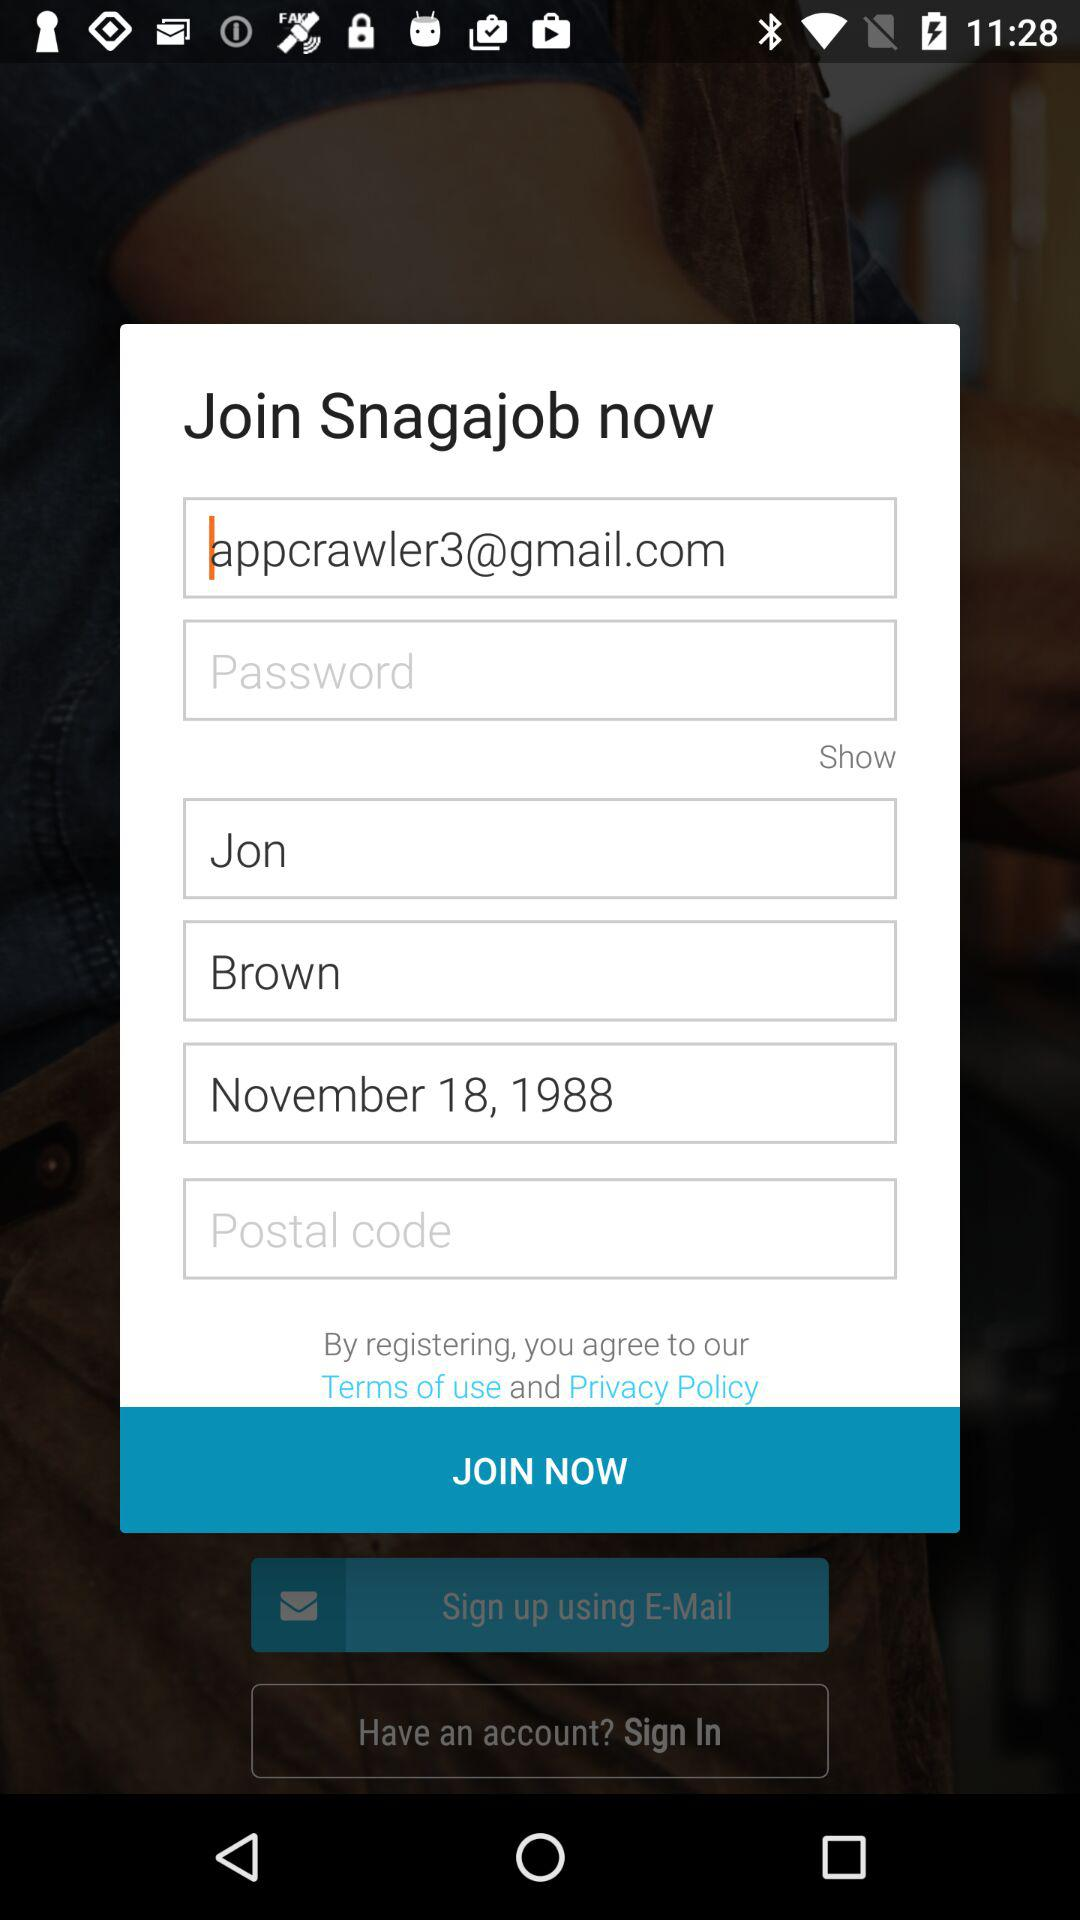What is the Gmail address? The Gmail address is appcrawler3@gmail.com. 